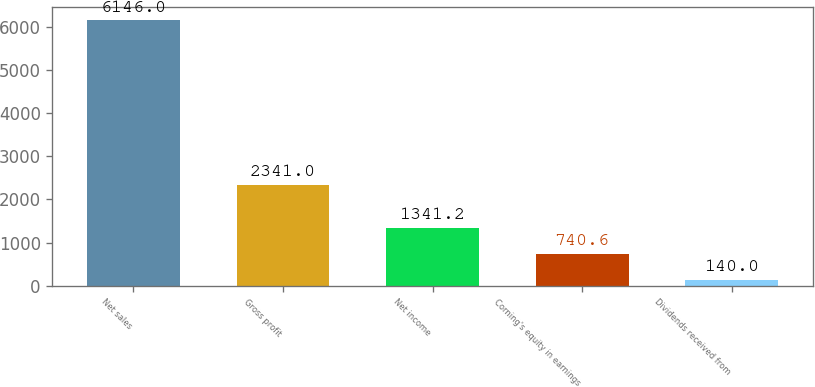Convert chart to OTSL. <chart><loc_0><loc_0><loc_500><loc_500><bar_chart><fcel>Net sales<fcel>Gross profit<fcel>Net income<fcel>Corning's equity in earnings<fcel>Dividends received from<nl><fcel>6146<fcel>2341<fcel>1341.2<fcel>740.6<fcel>140<nl></chart> 